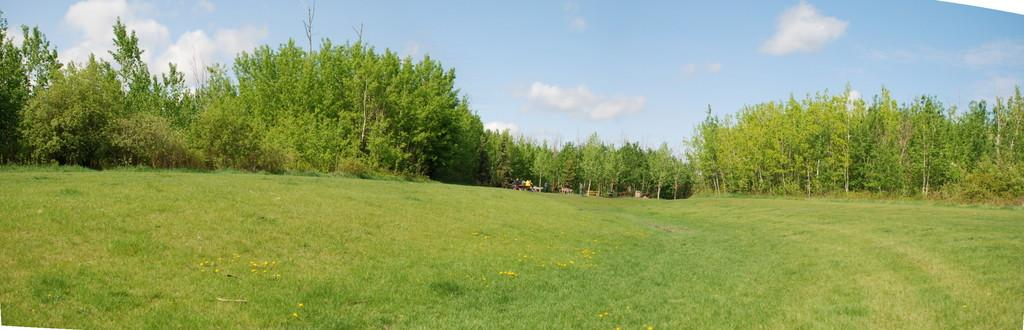What type of vegetation can be seen in the image? There is grass in the image. What other natural elements are present in the image? There are trees in the image. What can be seen in the sky in the image? There are clouds visible in the image. What type of leather is being used to make the basin in the image? There is no basin or leather present in the image; it features grass, trees, and clouds. 